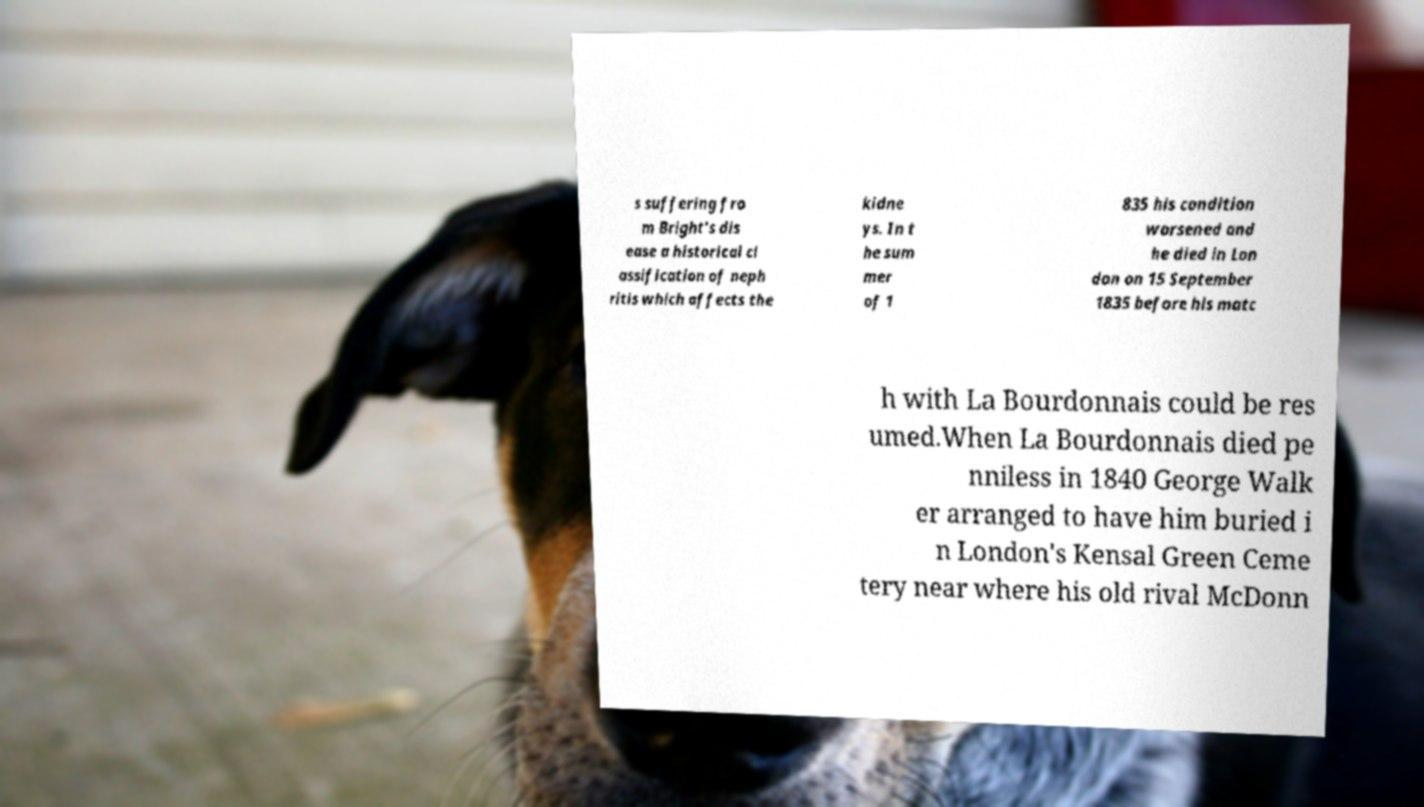Please read and relay the text visible in this image. What does it say? s suffering fro m Bright's dis ease a historical cl assification of neph ritis which affects the kidne ys. In t he sum mer of 1 835 his condition worsened and he died in Lon don on 15 September 1835 before his matc h with La Bourdonnais could be res umed.When La Bourdonnais died pe nniless in 1840 George Walk er arranged to have him buried i n London's Kensal Green Ceme tery near where his old rival McDonn 